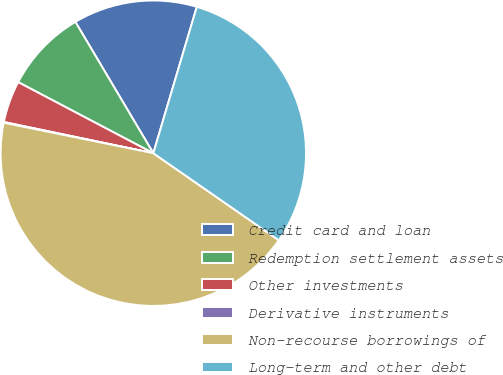Convert chart to OTSL. <chart><loc_0><loc_0><loc_500><loc_500><pie_chart><fcel>Credit card and loan<fcel>Redemption settlement assets<fcel>Other investments<fcel>Derivative instruments<fcel>Non-recourse borrowings of<fcel>Long-term and other debt<nl><fcel>13.12%<fcel>8.77%<fcel>4.43%<fcel>0.08%<fcel>43.55%<fcel>30.06%<nl></chart> 